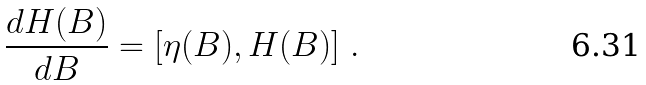Convert formula to latex. <formula><loc_0><loc_0><loc_500><loc_500>\frac { d H ( B ) } { d B } = [ \eta ( B ) , H ( B ) ] \ .</formula> 